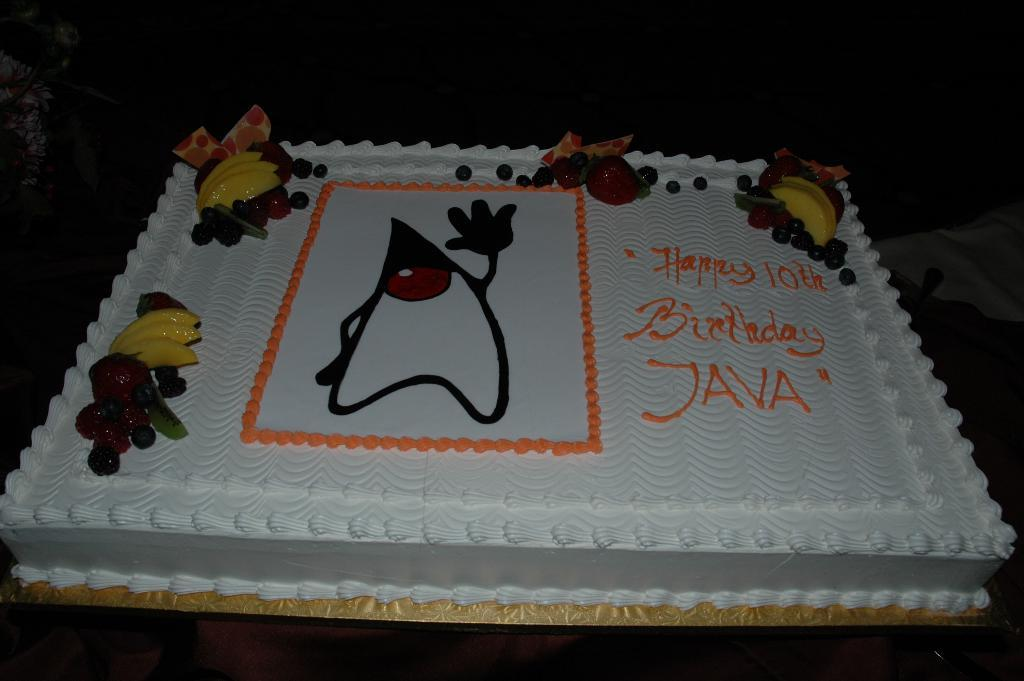What is the main subject of the image? There is a birthday cake in the image. What message is written on the cake? The cake has "Happy 10th birthday Java" written on it. What is the color of the background in the image? The background of the image is black. Can you describe the lighting conditions in the image? The image might have been taken in a dark environment, as indicated by the black background. What type of scarf is draped over the sheep in the image? There is no scarf or sheep present in the image; it features a birthday cake with a message. 